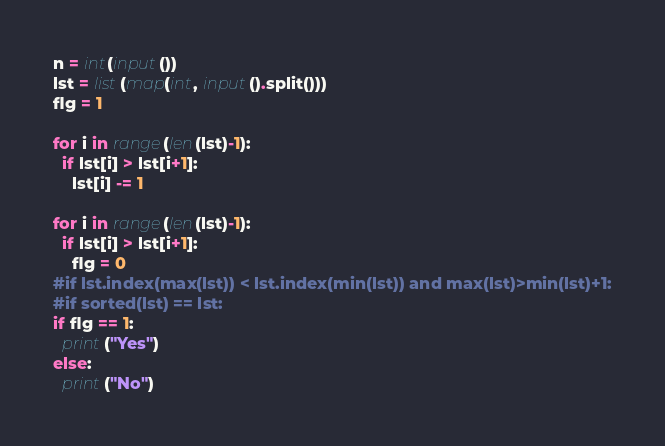Convert code to text. <code><loc_0><loc_0><loc_500><loc_500><_Python_>n = int(input())
lst = list(map(int, input().split()))
flg = 1

for i in range(len(lst)-1):
  if lst[i] > lst[i+1]:
    lst[i] -= 1

for i in range(len(lst)-1):
  if lst[i] > lst[i+1]:
    flg = 0
#if lst.index(max(lst)) < lst.index(min(lst)) and max(lst)>min(lst)+1:
#if sorted(lst) == lst:
if flg == 1:
  print("Yes")
else:
  print("No")</code> 